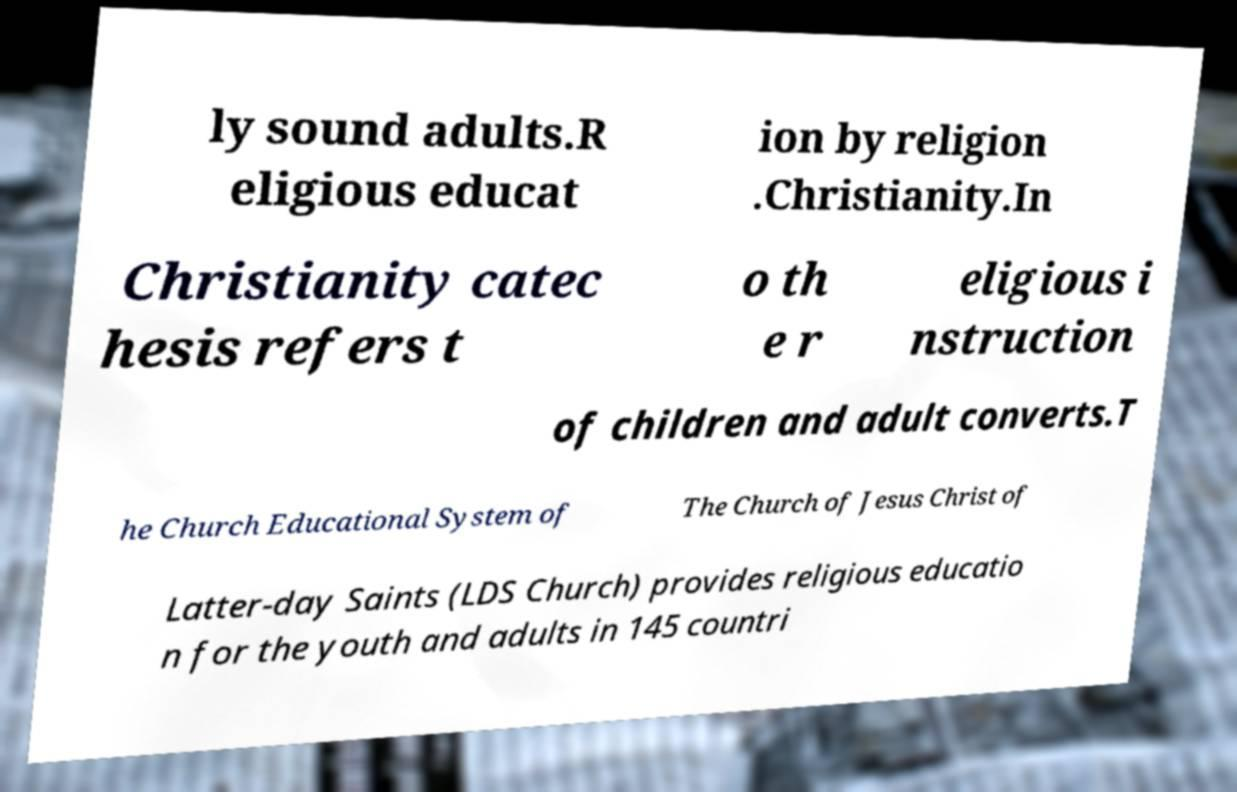Please read and relay the text visible in this image. What does it say? ly sound adults.R eligious educat ion by religion .Christianity.In Christianity catec hesis refers t o th e r eligious i nstruction of children and adult converts.T he Church Educational System of The Church of Jesus Christ of Latter-day Saints (LDS Church) provides religious educatio n for the youth and adults in 145 countri 